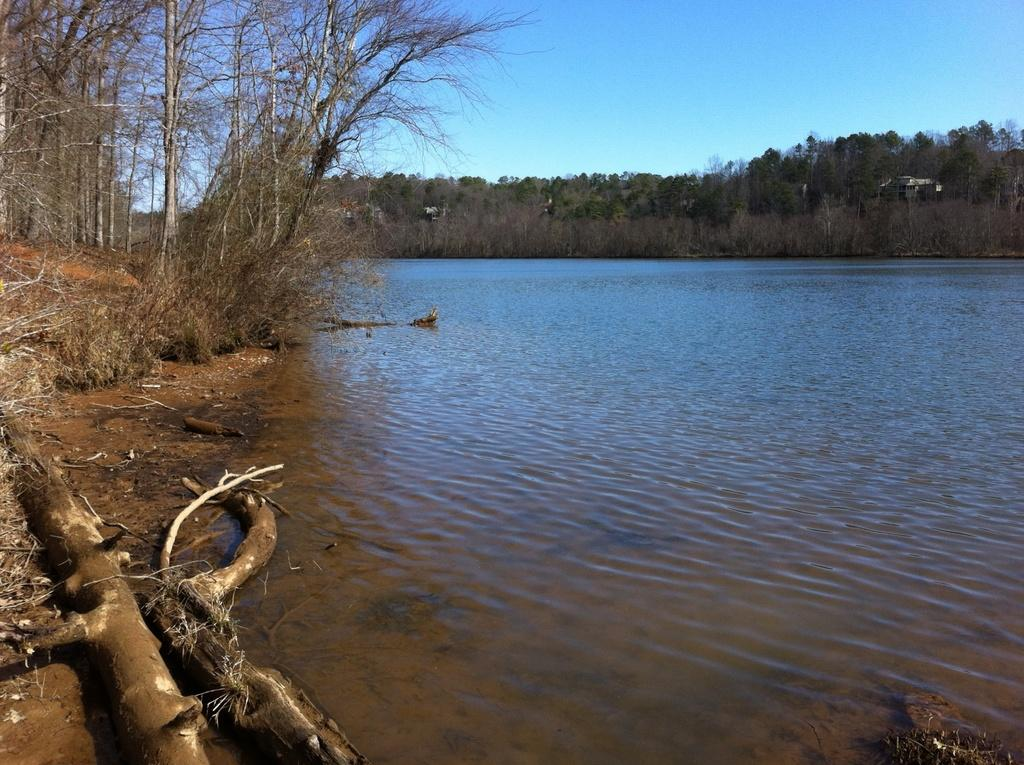What is located in the middle of the image? There is water in the middle of the image. What can be seen on either side of the water? There are trees on either side of the water. What is visible at the top of the image? The sky is visible at the top of the image. What is present on the left side of the image? There are dried logs on the left side of the image. Where is the faucet located in the image? There is no faucet present in the image. What type of beast can be seen interacting with the dried logs in the image? There is no beast present in the image, and therefore no such interaction can be observed. 